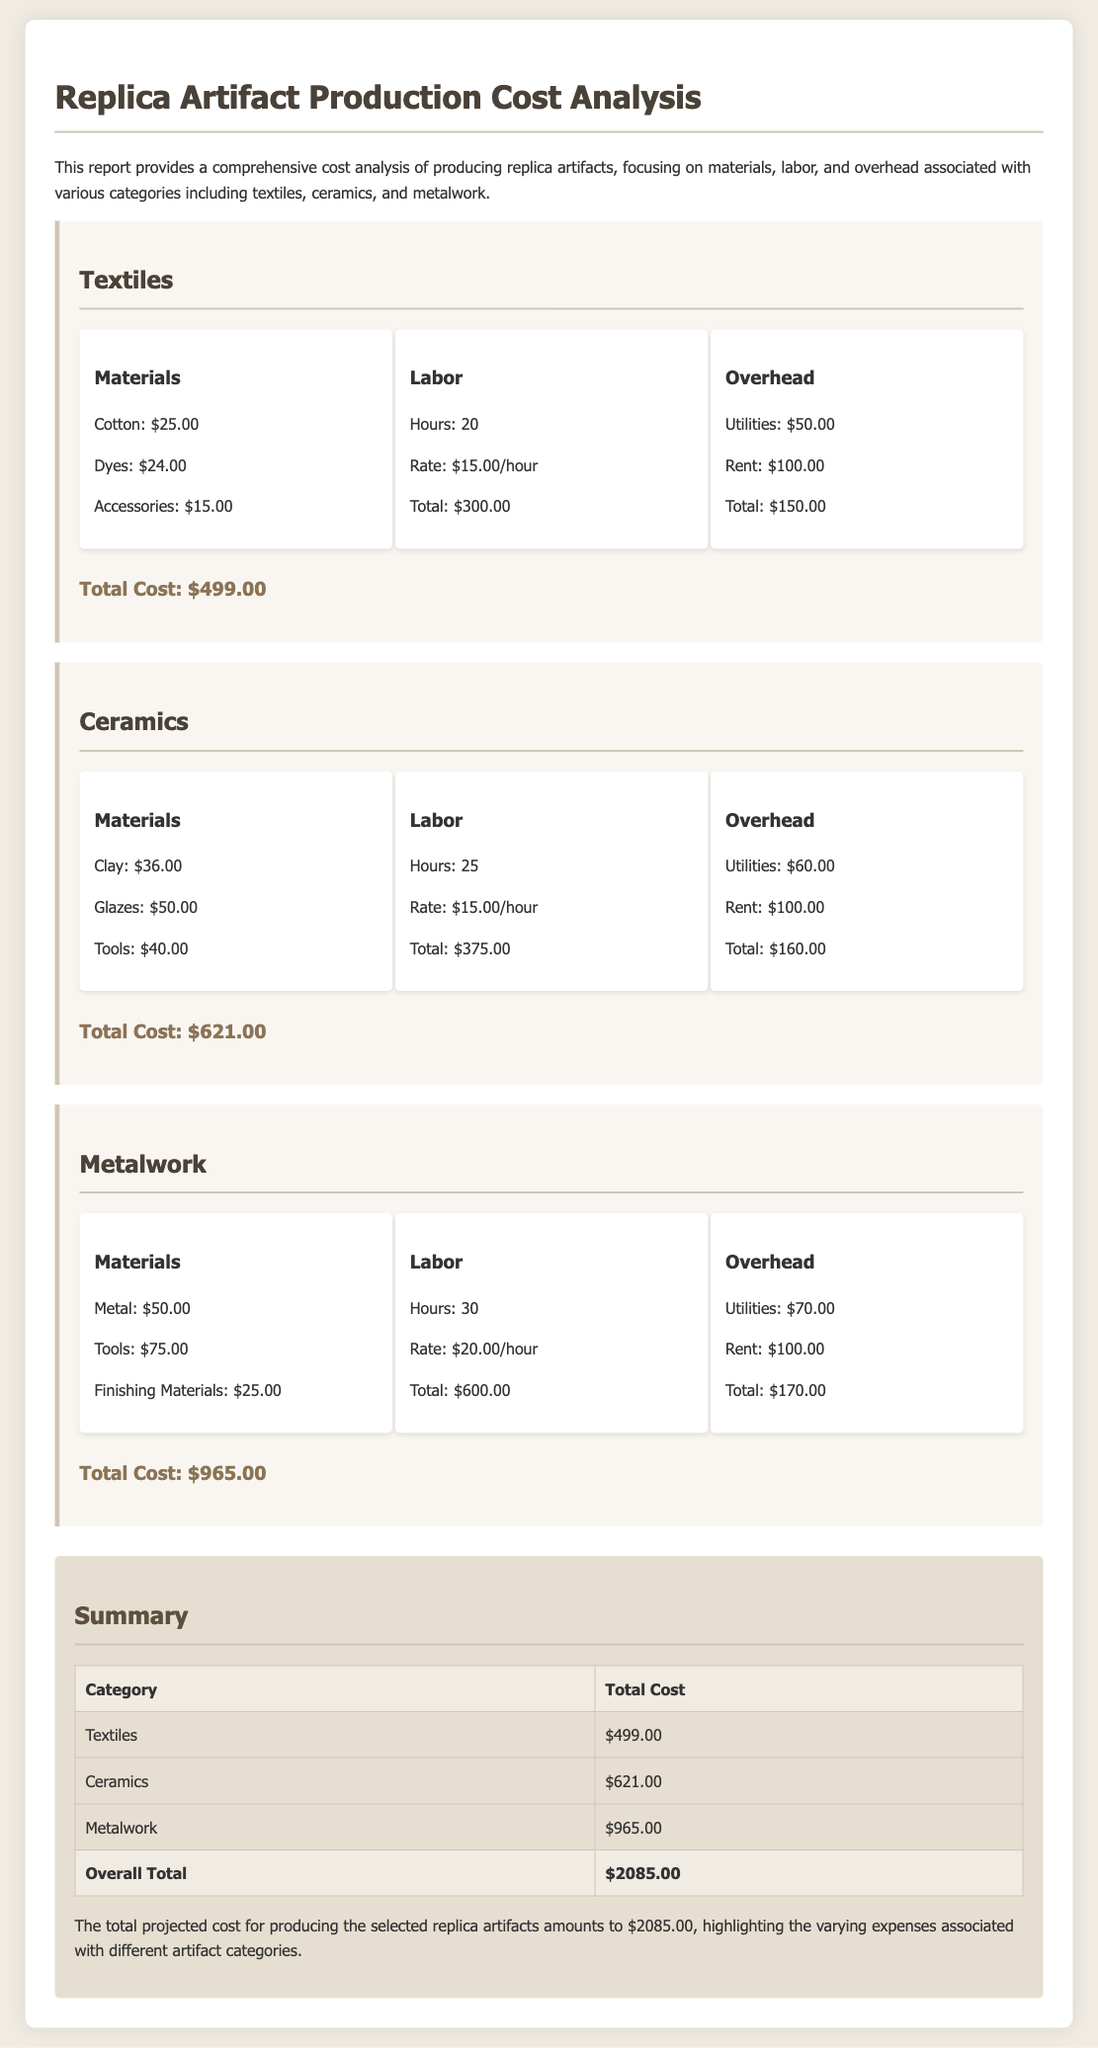What is the total cost for textiles? The total cost for textiles is provided at the end of the textile section, which is $499.00.
Answer: $499.00 What are the materials cost for ceramics? The materials cost for ceramics includes Clay, Glazes, and Tools, which totals $126.00 ($36.00 + $50.00 + $40.00).
Answer: $126.00 How much is the labor cost for metalwork? The labor cost for metalwork is mentioned as $600.00 based on the hours worked and rate.
Answer: $600.00 What is the total overhead for textiles? The total overhead for textiles is calculated by adding utilities and rent, which equals $150.00 ($50.00 + $100.00).
Answer: $150.00 Which artifact category has the highest total cost? The document lists the total costs for each category, showing that Metalwork has the highest total cost of $965.00.
Answer: Metalwork What was the total projected cost for all artifacts? The total projected cost is presented in the summary section, which is the overall total of all categories, amounting to $2085.00.
Answer: $2085.00 How many hours of labor are estimated for ceramics? The labor hours estimated for ceramics can be found in the ceramics section, which states 25 hours.
Answer: 25 What is the utility cost in the overhead for metalwork? The utility cost in the overhead for metalwork is specifically noted as $70.00 in its section.
Answer: $70.00 What are the total materials costs for textiles? The total materials cost for textiles includes Cotton, Dyes, and Accessories, which sums to $64.00 ($25.00 + $24.00 + $15.00).
Answer: $64.00 